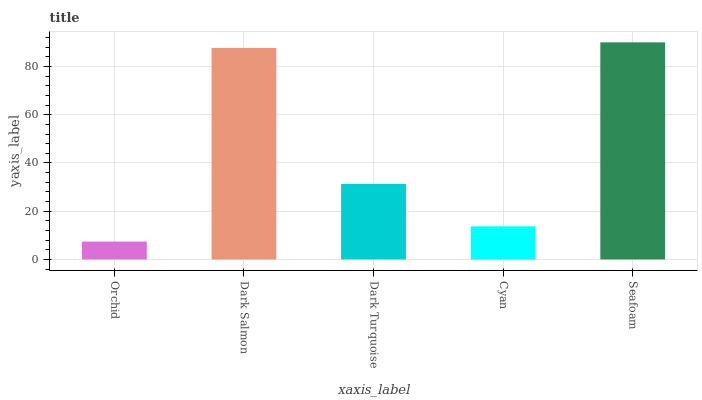Is Orchid the minimum?
Answer yes or no. Yes. Is Seafoam the maximum?
Answer yes or no. Yes. Is Dark Salmon the minimum?
Answer yes or no. No. Is Dark Salmon the maximum?
Answer yes or no. No. Is Dark Salmon greater than Orchid?
Answer yes or no. Yes. Is Orchid less than Dark Salmon?
Answer yes or no. Yes. Is Orchid greater than Dark Salmon?
Answer yes or no. No. Is Dark Salmon less than Orchid?
Answer yes or no. No. Is Dark Turquoise the high median?
Answer yes or no. Yes. Is Dark Turquoise the low median?
Answer yes or no. Yes. Is Orchid the high median?
Answer yes or no. No. Is Cyan the low median?
Answer yes or no. No. 